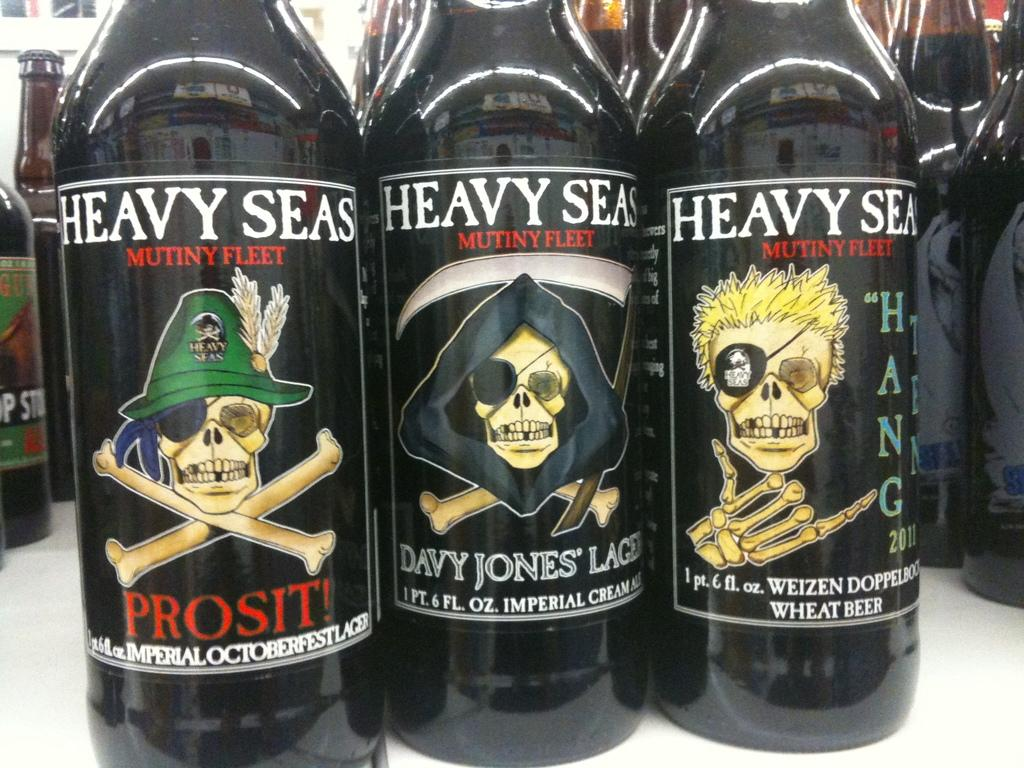What objects can be seen in the image? There are bottles in the image. What distinguishing feature do the bottles have? The bottles have labels on them. What type of sack is being used to store the produce in the image? There is no sack or produce present in the image; it only features bottles with labels. 